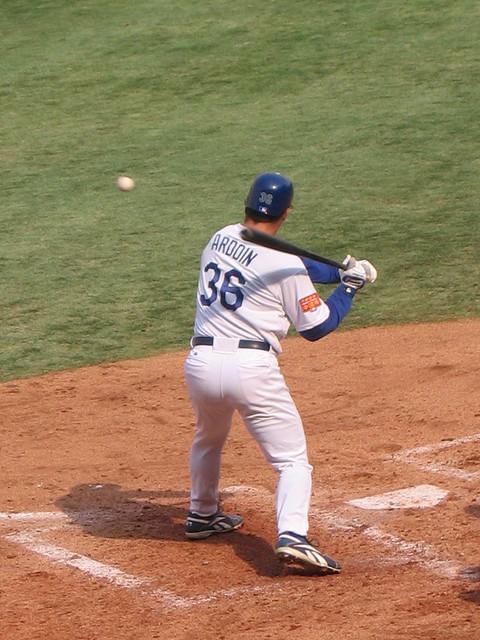What brand are the man's shoes?
Concise answer only. Nike. What number is on the hitter's jersey?
Be succinct. 36. What position is he playing?
Write a very short answer. Batter. What number is on the player's jersey?
Concise answer only. 36. Is the man wearing red?
Concise answer only. No. For what team does the player on the left play?
Be succinct. Boston. Is the batter left or right handed?
Answer briefly. Right. Will he strike out?
Give a very brief answer. No. What position is this baseball player playing?
Be succinct. Batter. Did he hit the ball yet?
Concise answer only. No. 